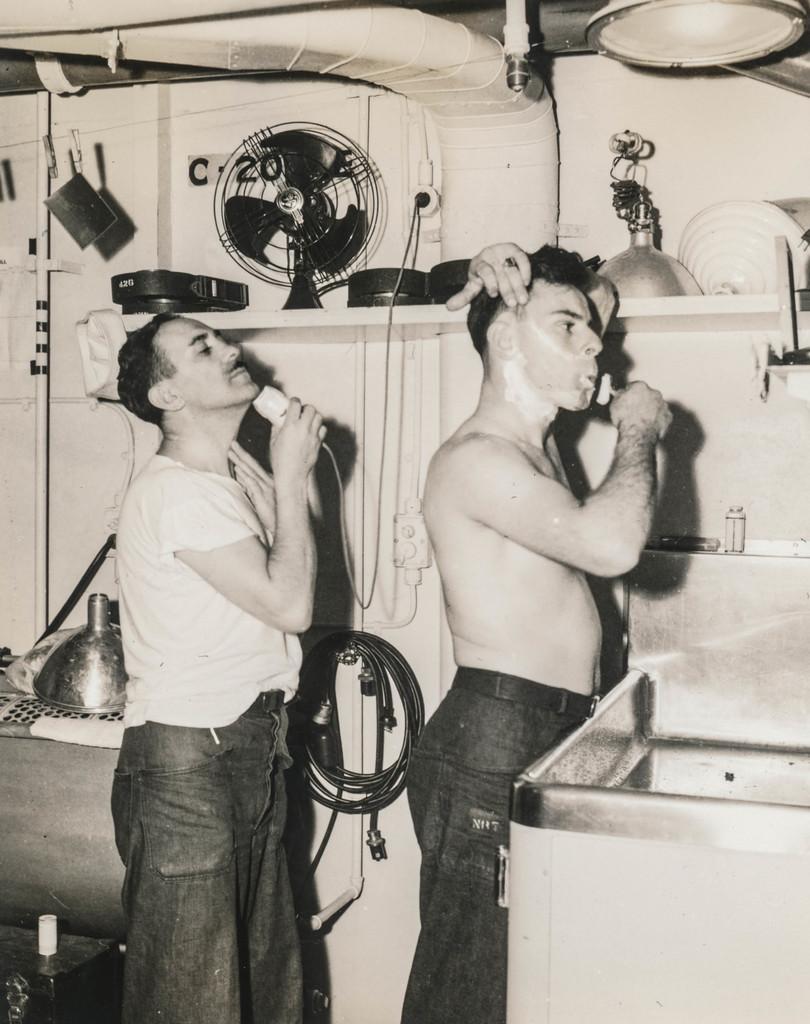Could you give a brief overview of what you see in this image? In this picture there is a man who is wearing jeans, standing near to the wash basin and he is holding cutter. Here we can see another man who is wearing t-shirt, jeans and holding a trimmer. On the top we can see duct, pipe and light. In this rock we can see fan, lamp and box. On the left there is a pipe on the wall. On the bottom left corner there is a wine bottle near to the table. 